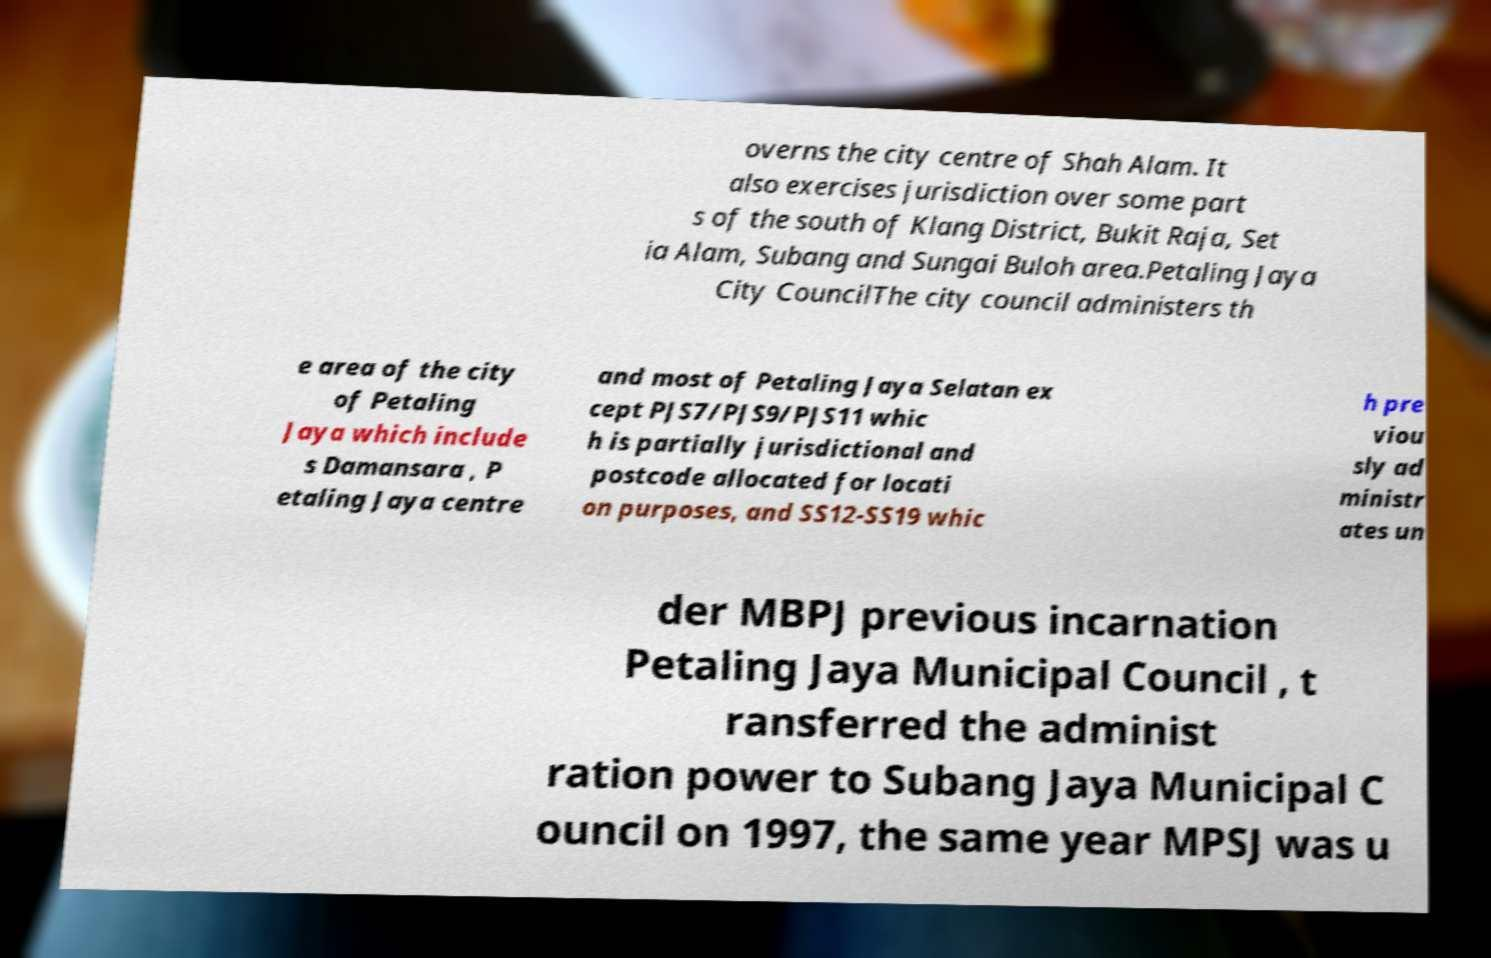Can you accurately transcribe the text from the provided image for me? overns the city centre of Shah Alam. It also exercises jurisdiction over some part s of the south of Klang District, Bukit Raja, Set ia Alam, Subang and Sungai Buloh area.Petaling Jaya City CouncilThe city council administers th e area of the city of Petaling Jaya which include s Damansara , P etaling Jaya centre and most of Petaling Jaya Selatan ex cept PJS7/PJS9/PJS11 whic h is partially jurisdictional and postcode allocated for locati on purposes, and SS12-SS19 whic h pre viou sly ad ministr ates un der MBPJ previous incarnation Petaling Jaya Municipal Council , t ransferred the administ ration power to Subang Jaya Municipal C ouncil on 1997, the same year MPSJ was u 